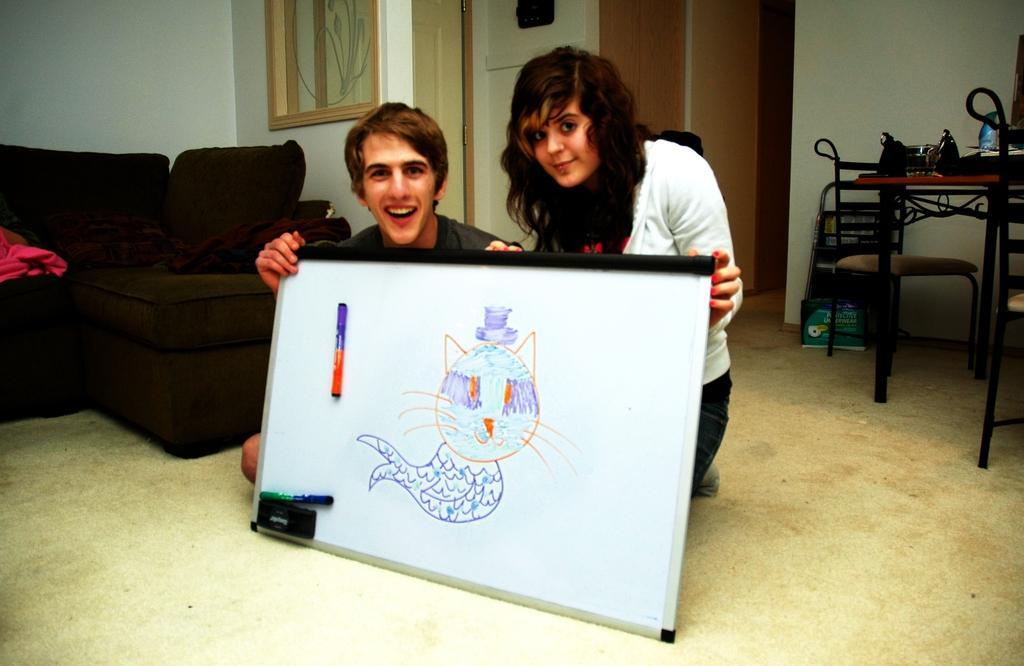Please provide a concise description of this image. It is inside the house, it is a living room there is a big sofa beside, the sofa men and women are sitting on the floor both of them are holding a drawing in their hands,behind them there is a table and chairs ,in the background is a door and a wall. 